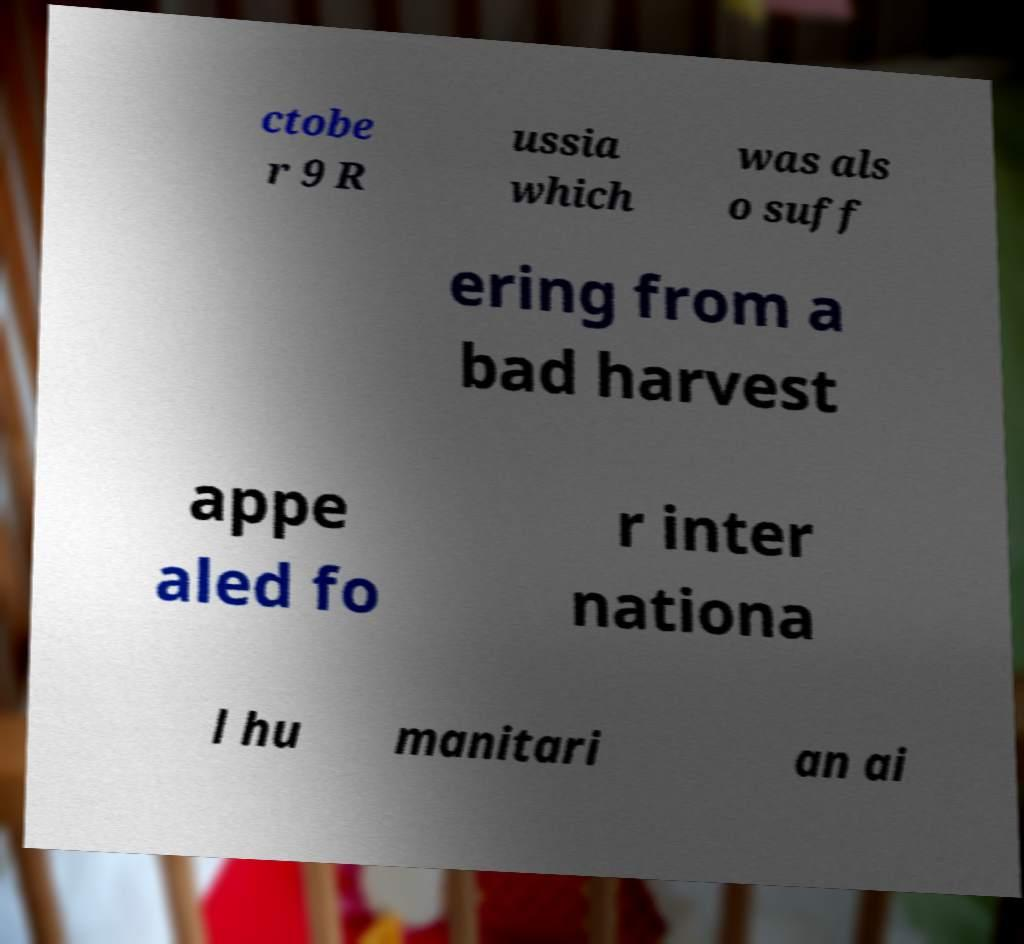Can you accurately transcribe the text from the provided image for me? ctobe r 9 R ussia which was als o suff ering from a bad harvest appe aled fo r inter nationa l hu manitari an ai 